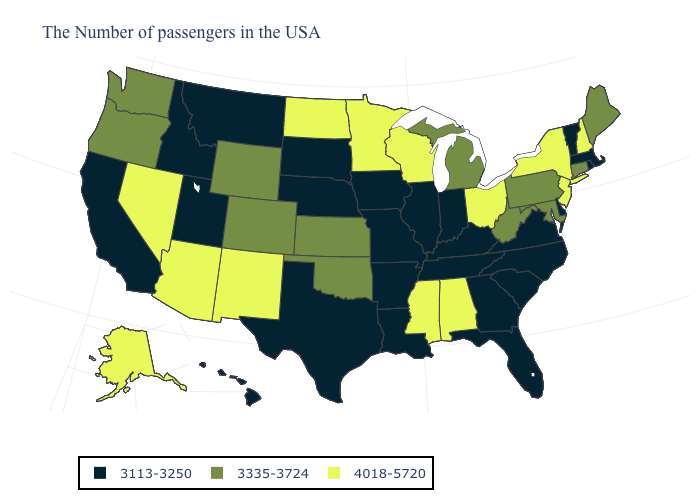Does Tennessee have the same value as Massachusetts?
Write a very short answer. Yes. What is the value of Arizona?
Concise answer only. 4018-5720. Which states have the lowest value in the USA?
Keep it brief. Massachusetts, Rhode Island, Vermont, Delaware, Virginia, North Carolina, South Carolina, Florida, Georgia, Kentucky, Indiana, Tennessee, Illinois, Louisiana, Missouri, Arkansas, Iowa, Nebraska, Texas, South Dakota, Utah, Montana, Idaho, California, Hawaii. What is the lowest value in the MidWest?
Quick response, please. 3113-3250. Does Illinois have the highest value in the USA?
Short answer required. No. Does Colorado have a higher value than Minnesota?
Keep it brief. No. What is the highest value in the USA?
Quick response, please. 4018-5720. Name the states that have a value in the range 3335-3724?
Quick response, please. Maine, Connecticut, Maryland, Pennsylvania, West Virginia, Michigan, Kansas, Oklahoma, Wyoming, Colorado, Washington, Oregon. Does West Virginia have a higher value than Minnesota?
Be succinct. No. What is the lowest value in the USA?
Be succinct. 3113-3250. Does California have the highest value in the USA?
Concise answer only. No. Is the legend a continuous bar?
Short answer required. No. Among the states that border Tennessee , which have the highest value?
Quick response, please. Alabama, Mississippi. 